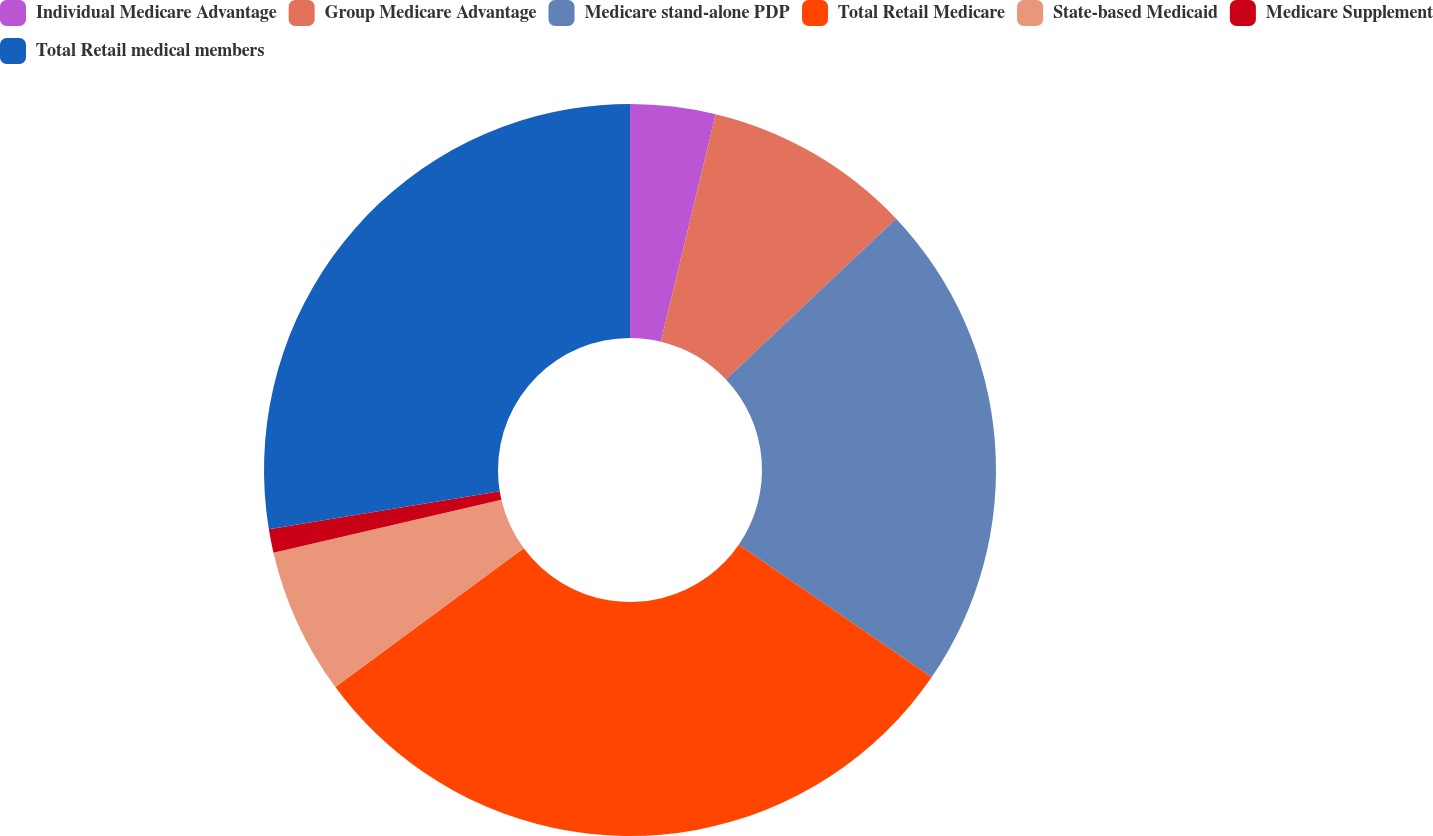Convert chart to OTSL. <chart><loc_0><loc_0><loc_500><loc_500><pie_chart><fcel>Individual Medicare Advantage<fcel>Group Medicare Advantage<fcel>Medicare stand-alone PDP<fcel>Total Retail Medicare<fcel>State-based Medicaid<fcel>Medicare Supplement<fcel>Total Retail medical members<nl><fcel>3.76%<fcel>9.2%<fcel>21.63%<fcel>30.31%<fcel>6.48%<fcel>1.04%<fcel>27.59%<nl></chart> 